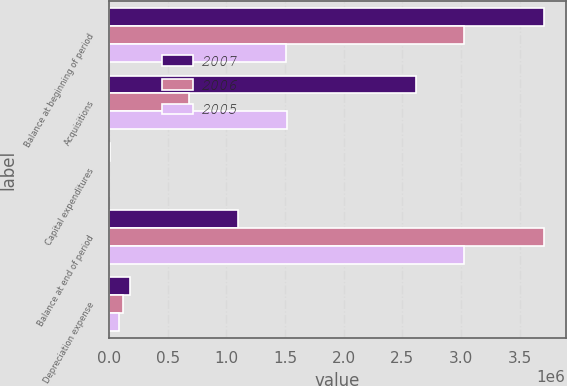Convert chart. <chart><loc_0><loc_0><loc_500><loc_500><stacked_bar_chart><ecel><fcel>Balance at beginning of period<fcel>Acquisitions<fcel>Capital expenditures<fcel>Balance at end of period<fcel>Depreciation expense<nl><fcel>2007<fcel>3.70784e+06<fcel>2.61905e+06<fcel>6372<fcel>1.09589e+06<fcel>175494<nl><fcel>2006<fcel>3.0279e+06<fcel>679573<fcel>368<fcel>3.70784e+06<fcel>118238<nl><fcel>2005<fcel>1.51221e+06<fcel>1.5211e+06<fcel>25<fcel>3.0279e+06<fcel>87559<nl></chart> 